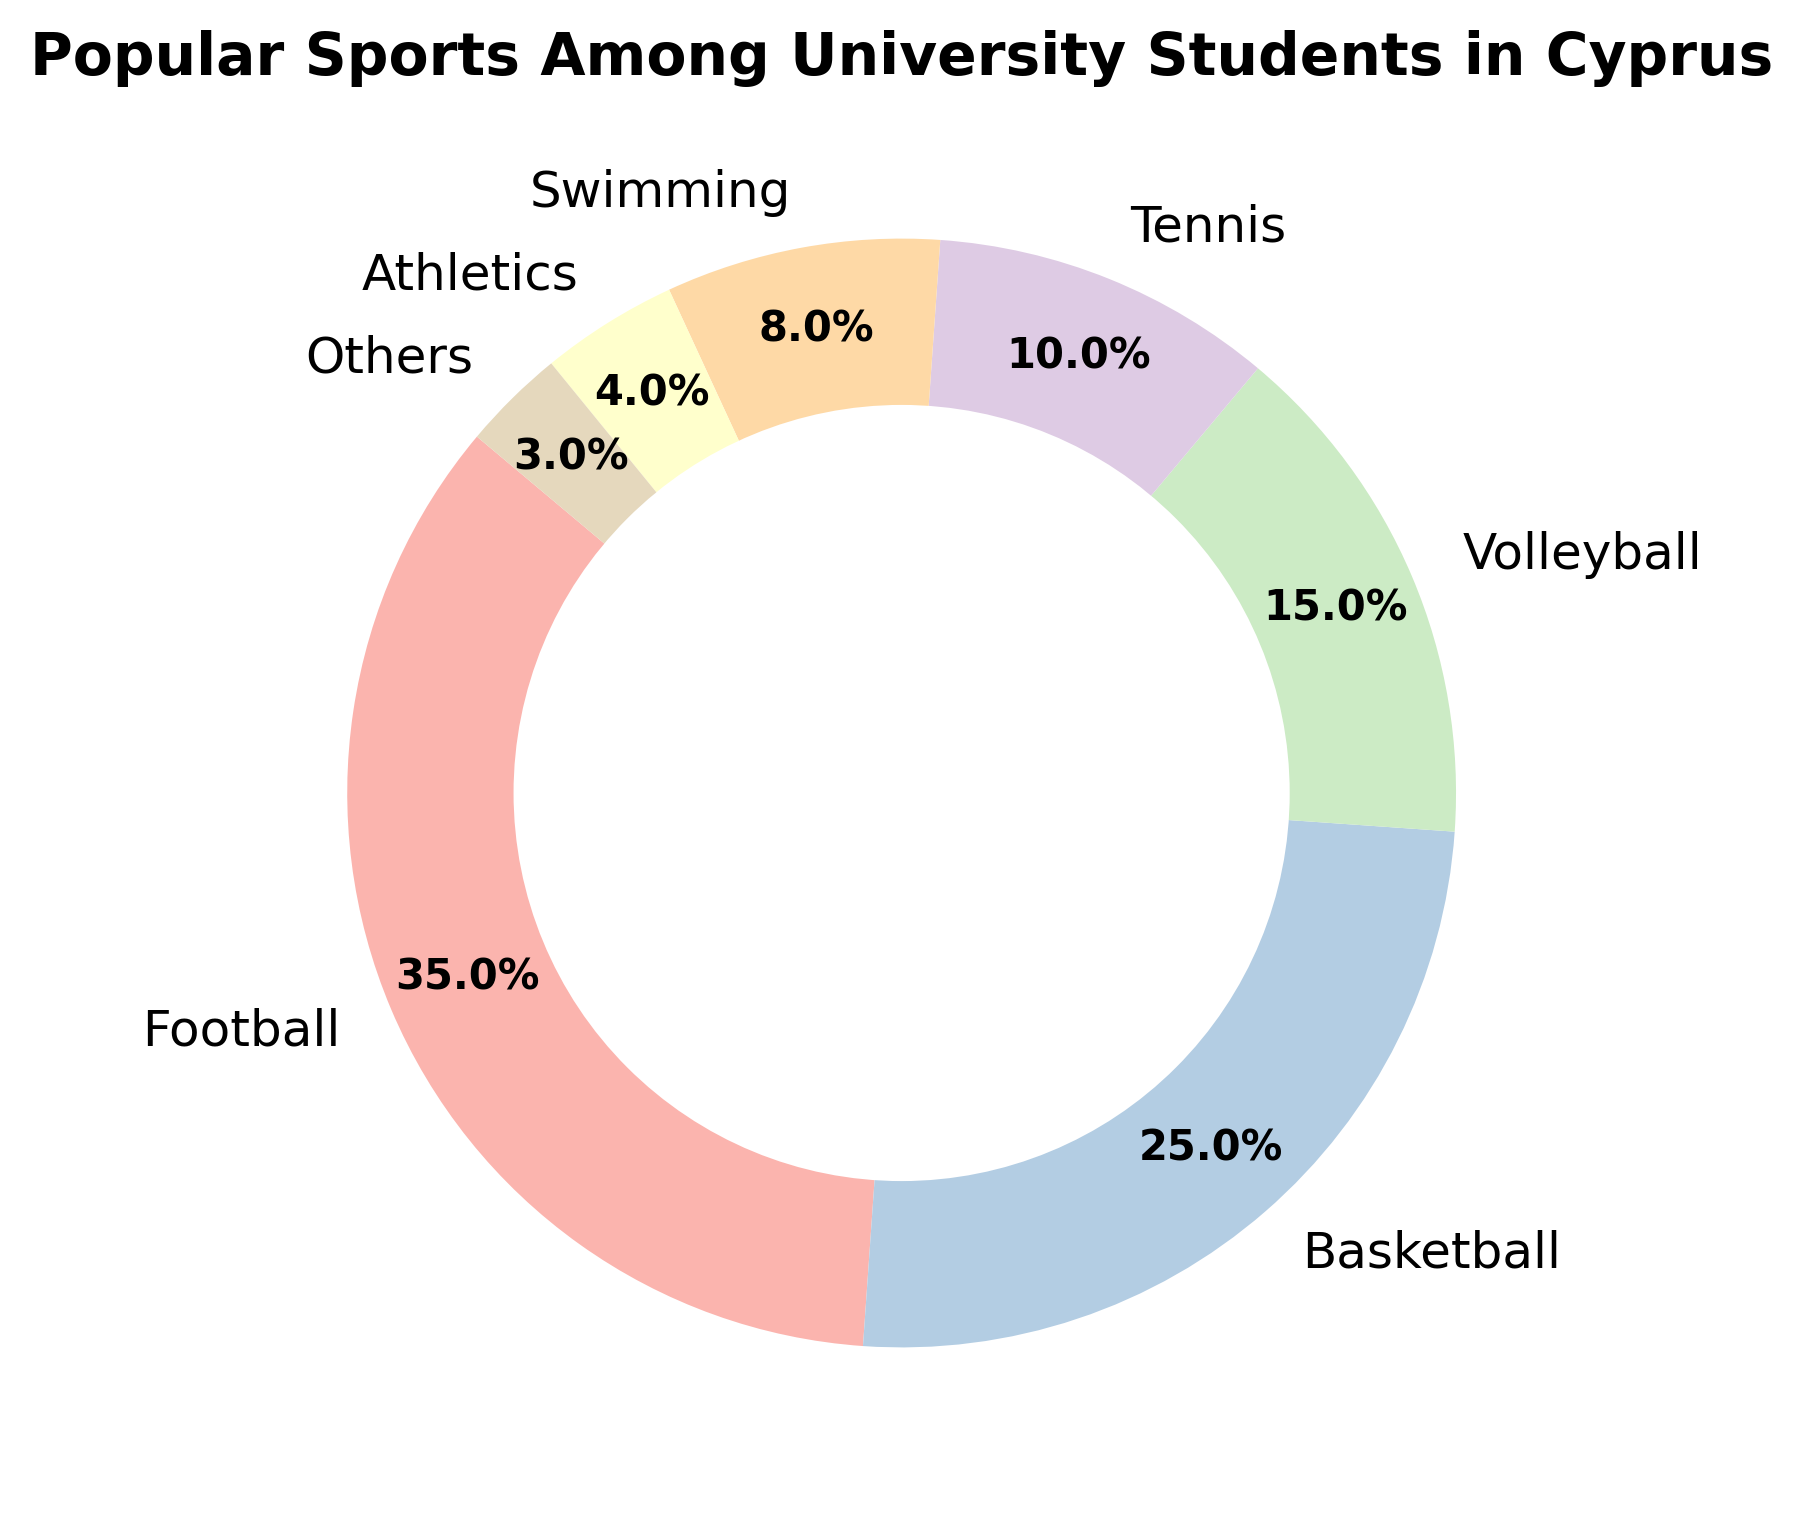Which sport is the most popular among university students in Cyprus? The chart title indicates "Popular Sports Among University Students in Cyprus", and from the pie chart, the largest slice represents Football.
Answer: Football What percentage of students prefer basketball? From the pie chart, the slice representing Basketball is labeled with a percentage, which is 25%.
Answer: 25% How much more popular is Football than Volleyball? Football has a popularity percentage of 35%, and Volleyball has 15%. The difference is 35% - 15% = 20%.
Answer: 20% Which sports have a combined popularity of more than 50%? Football (35%), Basketball (25%), Volleyball (15%), Tennis (10%), Swimming (8%), Athletics (4%), and Others (3%) are the segments. Football and Basketball together make 35% + 25% = 60%, which is more than 50%.
Answer: Football and Basketball Is Tennis more popular than Swimming? From the pie chart, Tennis has a popularity percentage of 10%, while Swimming has 8%. Since 10% is greater than 8%, Tennis is more popular.
Answer: Yes What is the total percentage of students participating in Athletics and Others? Athletics has a popularity percentage of 4% and Others have 3%. The sum is 4% + 3% = 7%.
Answer: 7% By how many percentage points does Football surpass the average popularity of all sports? First, calculate the average popularity: (35% + 25% + 15% + 10% + 8% + 4% + 3%) / 7 = 100% / 7 ≈ 14.29%. Football surpasses this average by 35% - 14.29% ≈ 20.71%.
Answer: About 20.71% Which sport occupies the smallest portion of the pie chart? The smallest slice of the pie chart represents Others, with 3%.
Answer: Others Is the popularity of Swimming closer to that of Tennis or Volleyball? Swimming has 8%, Tennis has 10% (difference of 2%), and Volleyball has 15% (difference of 7%). Since 2% is less than 7%, Swimming is closer to Tennis.
Answer: Tennis 